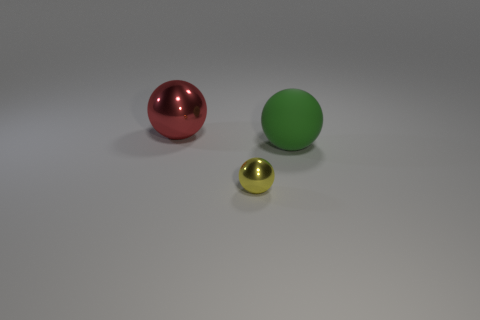Do the large object that is to the left of the green thing and the metallic object that is in front of the red metallic thing have the same shape?
Offer a terse response. Yes. There is a red object that is made of the same material as the tiny yellow ball; what size is it?
Keep it short and to the point. Large. Are there fewer matte balls than purple shiny balls?
Offer a terse response. No. What material is the big thing that is behind the big ball in front of the big ball to the left of the big green matte thing?
Offer a very short reply. Metal. Are the thing that is in front of the green matte thing and the object left of the yellow sphere made of the same material?
Provide a succinct answer. Yes. There is a object that is both to the left of the big green matte thing and right of the large red shiny thing; what is its size?
Your answer should be very brief. Small. What is the material of the object that is the same size as the red metal ball?
Make the answer very short. Rubber. How many metallic things are right of the shiny thing in front of the big thing that is behind the green matte sphere?
Give a very brief answer. 0. Do the metal object that is behind the tiny yellow ball and the metal object that is in front of the large green rubber object have the same color?
Offer a terse response. No. There is a ball that is behind the tiny sphere and left of the large green matte ball; what color is it?
Your answer should be compact. Red. 